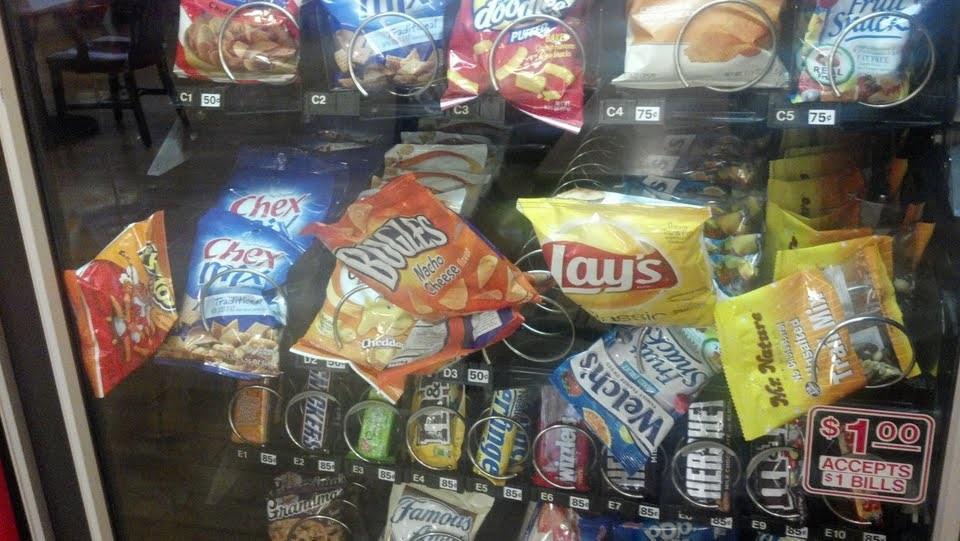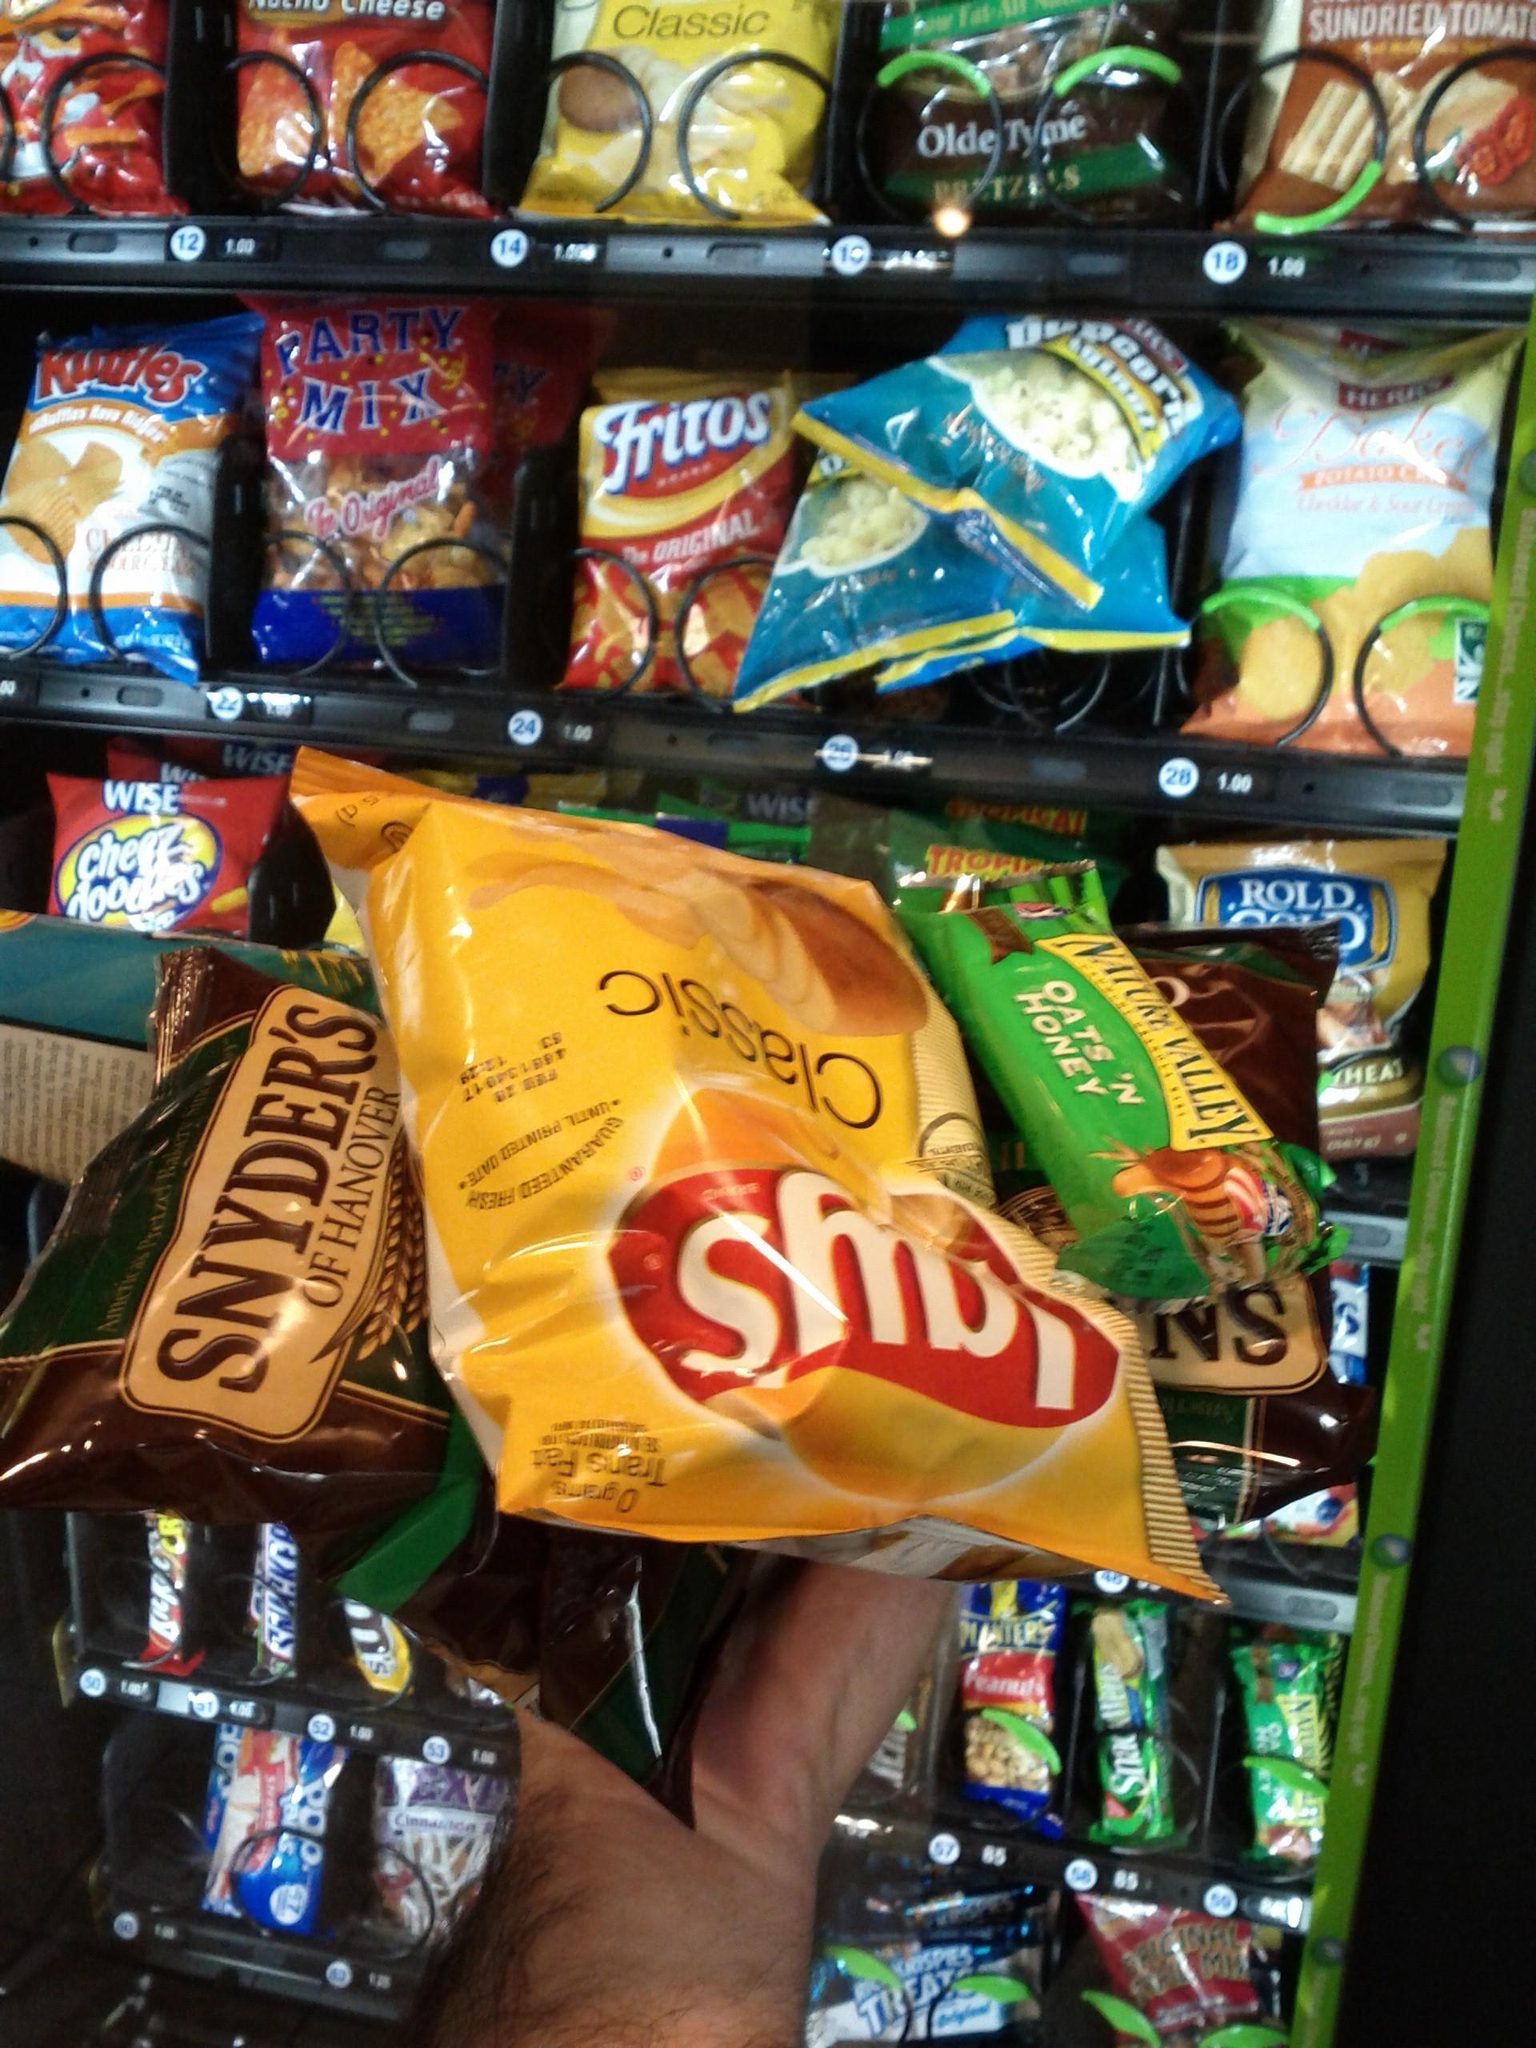The first image is the image on the left, the second image is the image on the right. Considering the images on both sides, is "At least one of the images shows snacks that have got stuck in a vending machine." valid? Answer yes or no. Yes. The first image is the image on the left, the second image is the image on the right. Examine the images to the left and right. Is the description "There are items falling from their shelves in both images." accurate? Answer yes or no. Yes. 